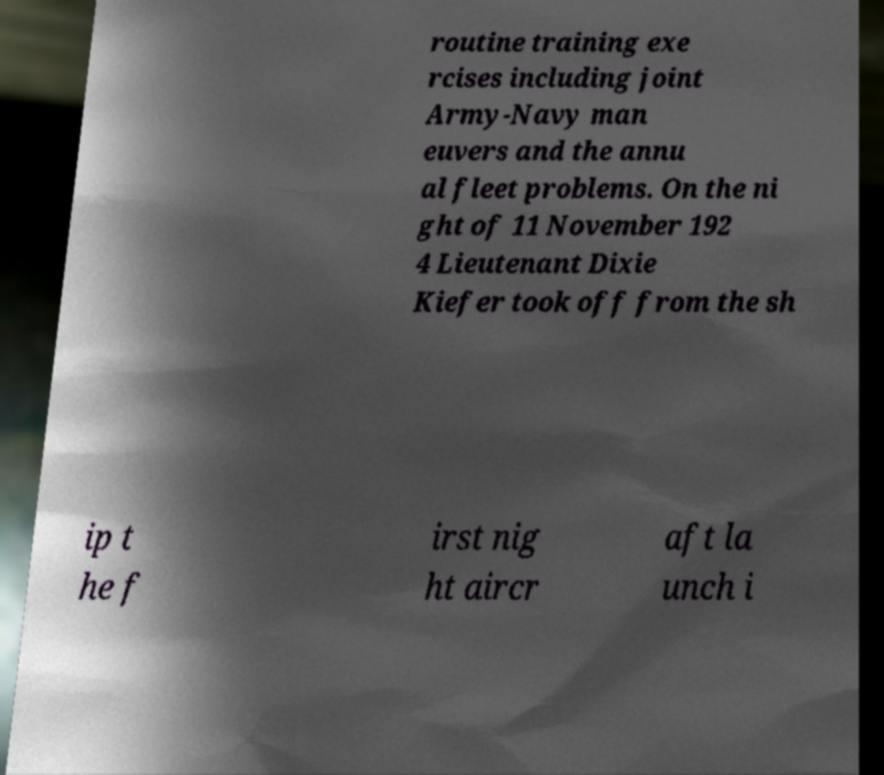I need the written content from this picture converted into text. Can you do that? routine training exe rcises including joint Army-Navy man euvers and the annu al fleet problems. On the ni ght of 11 November 192 4 Lieutenant Dixie Kiefer took off from the sh ip t he f irst nig ht aircr aft la unch i 